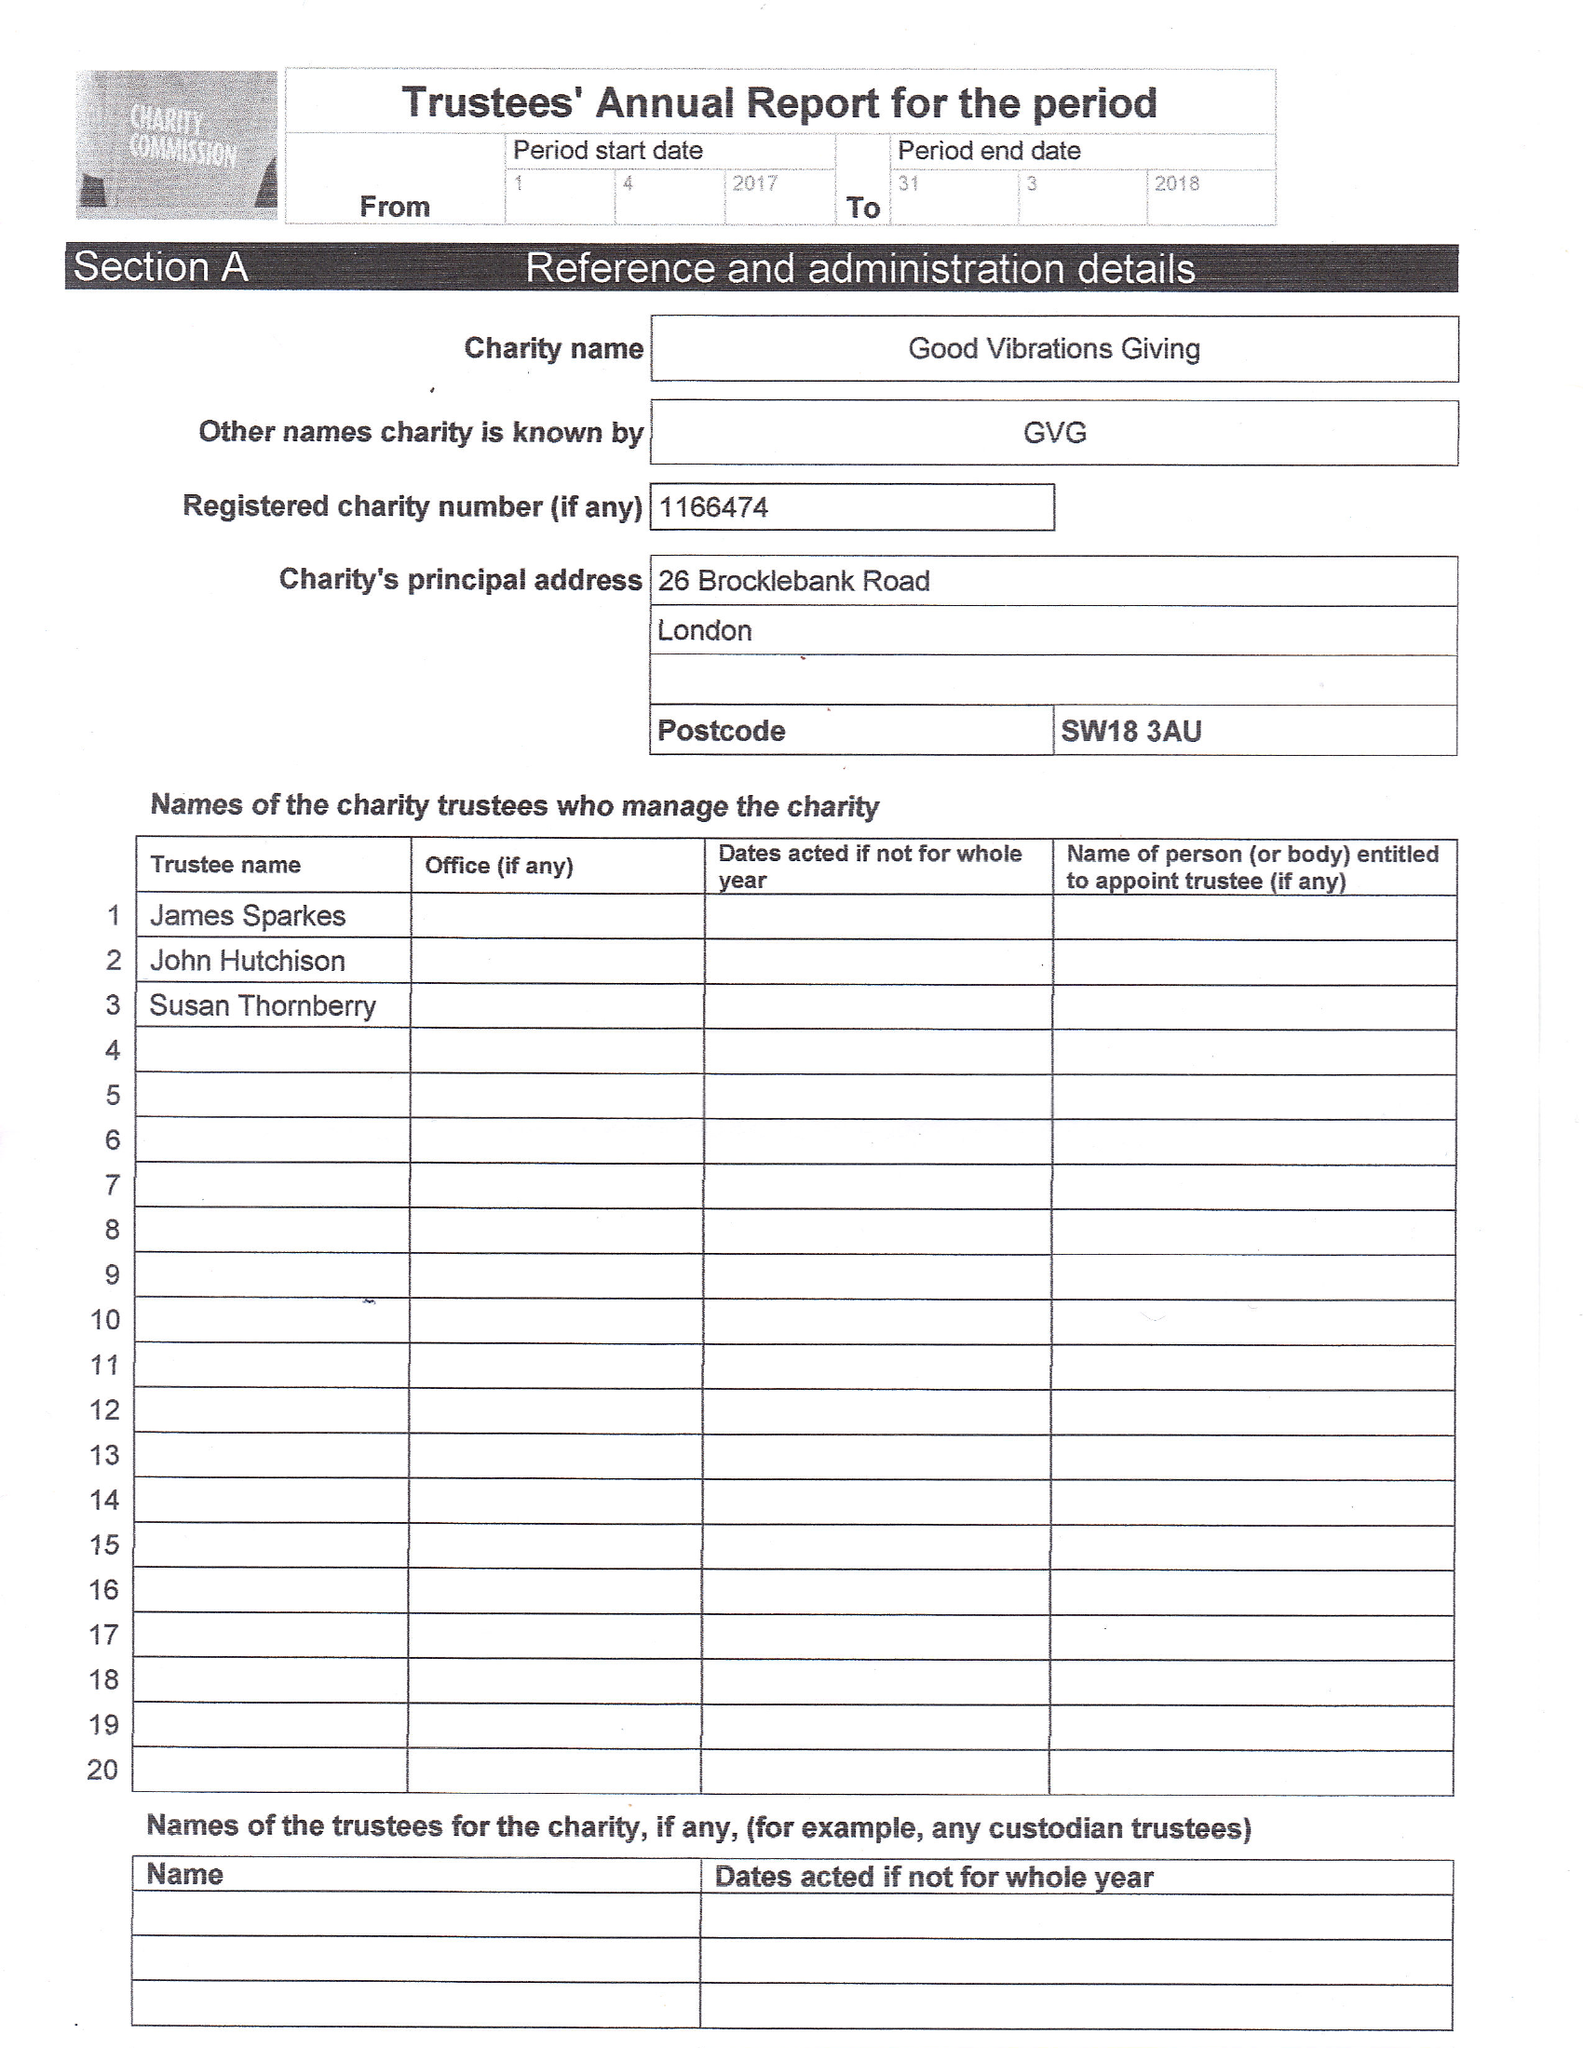What is the value for the address__post_town?
Answer the question using a single word or phrase. LONDON 